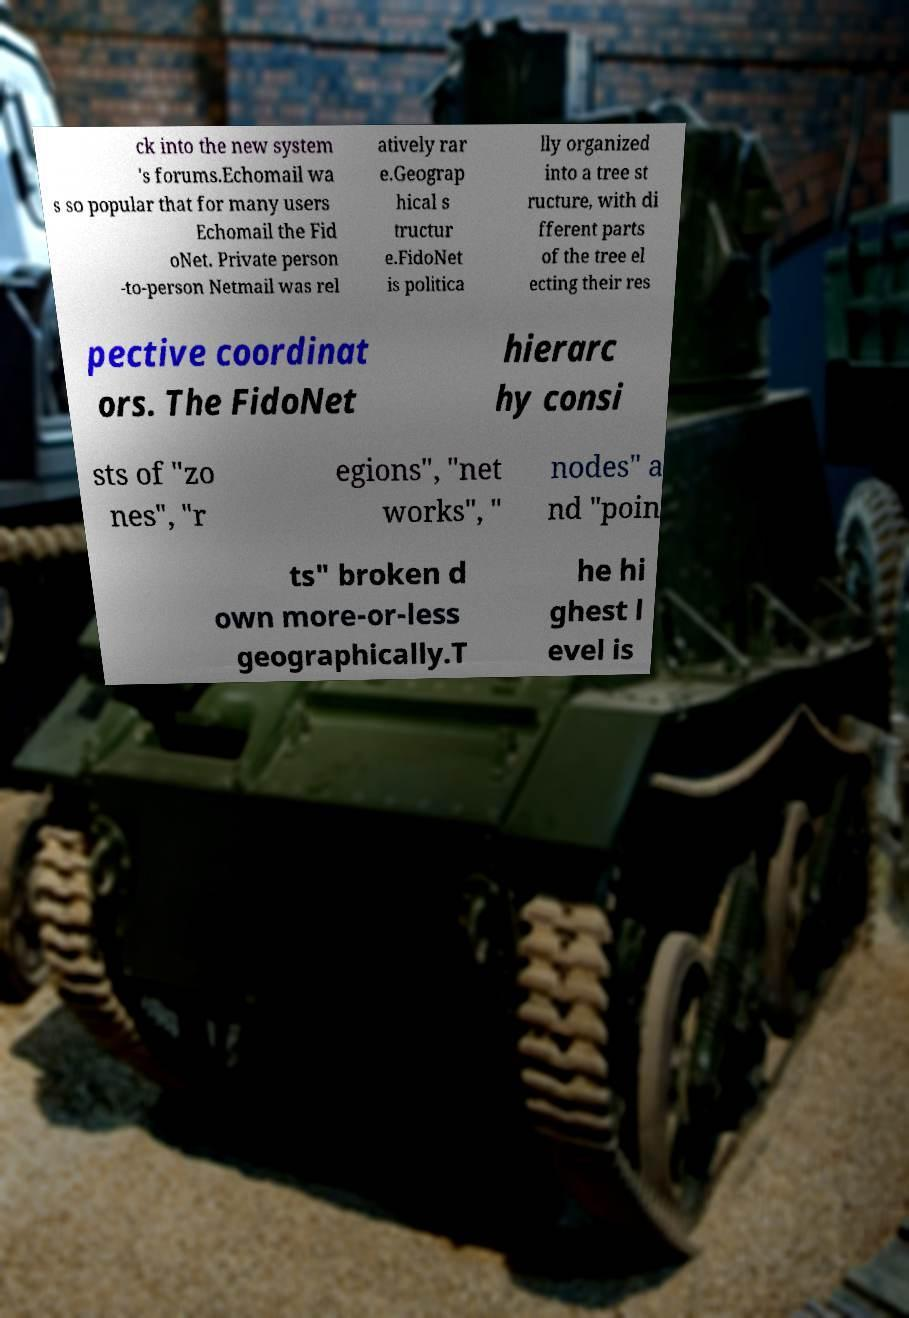Can you read and provide the text displayed in the image?This photo seems to have some interesting text. Can you extract and type it out for me? ck into the new system 's forums.Echomail wa s so popular that for many users Echomail the Fid oNet. Private person -to-person Netmail was rel atively rar e.Geograp hical s tructur e.FidoNet is politica lly organized into a tree st ructure, with di fferent parts of the tree el ecting their res pective coordinat ors. The FidoNet hierarc hy consi sts of "zo nes", "r egions", "net works", " nodes" a nd "poin ts" broken d own more-or-less geographically.T he hi ghest l evel is 